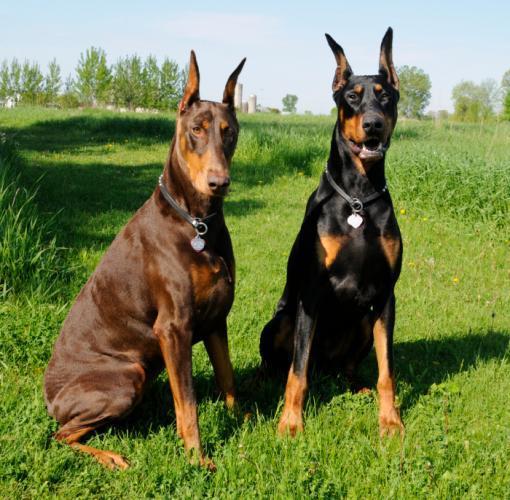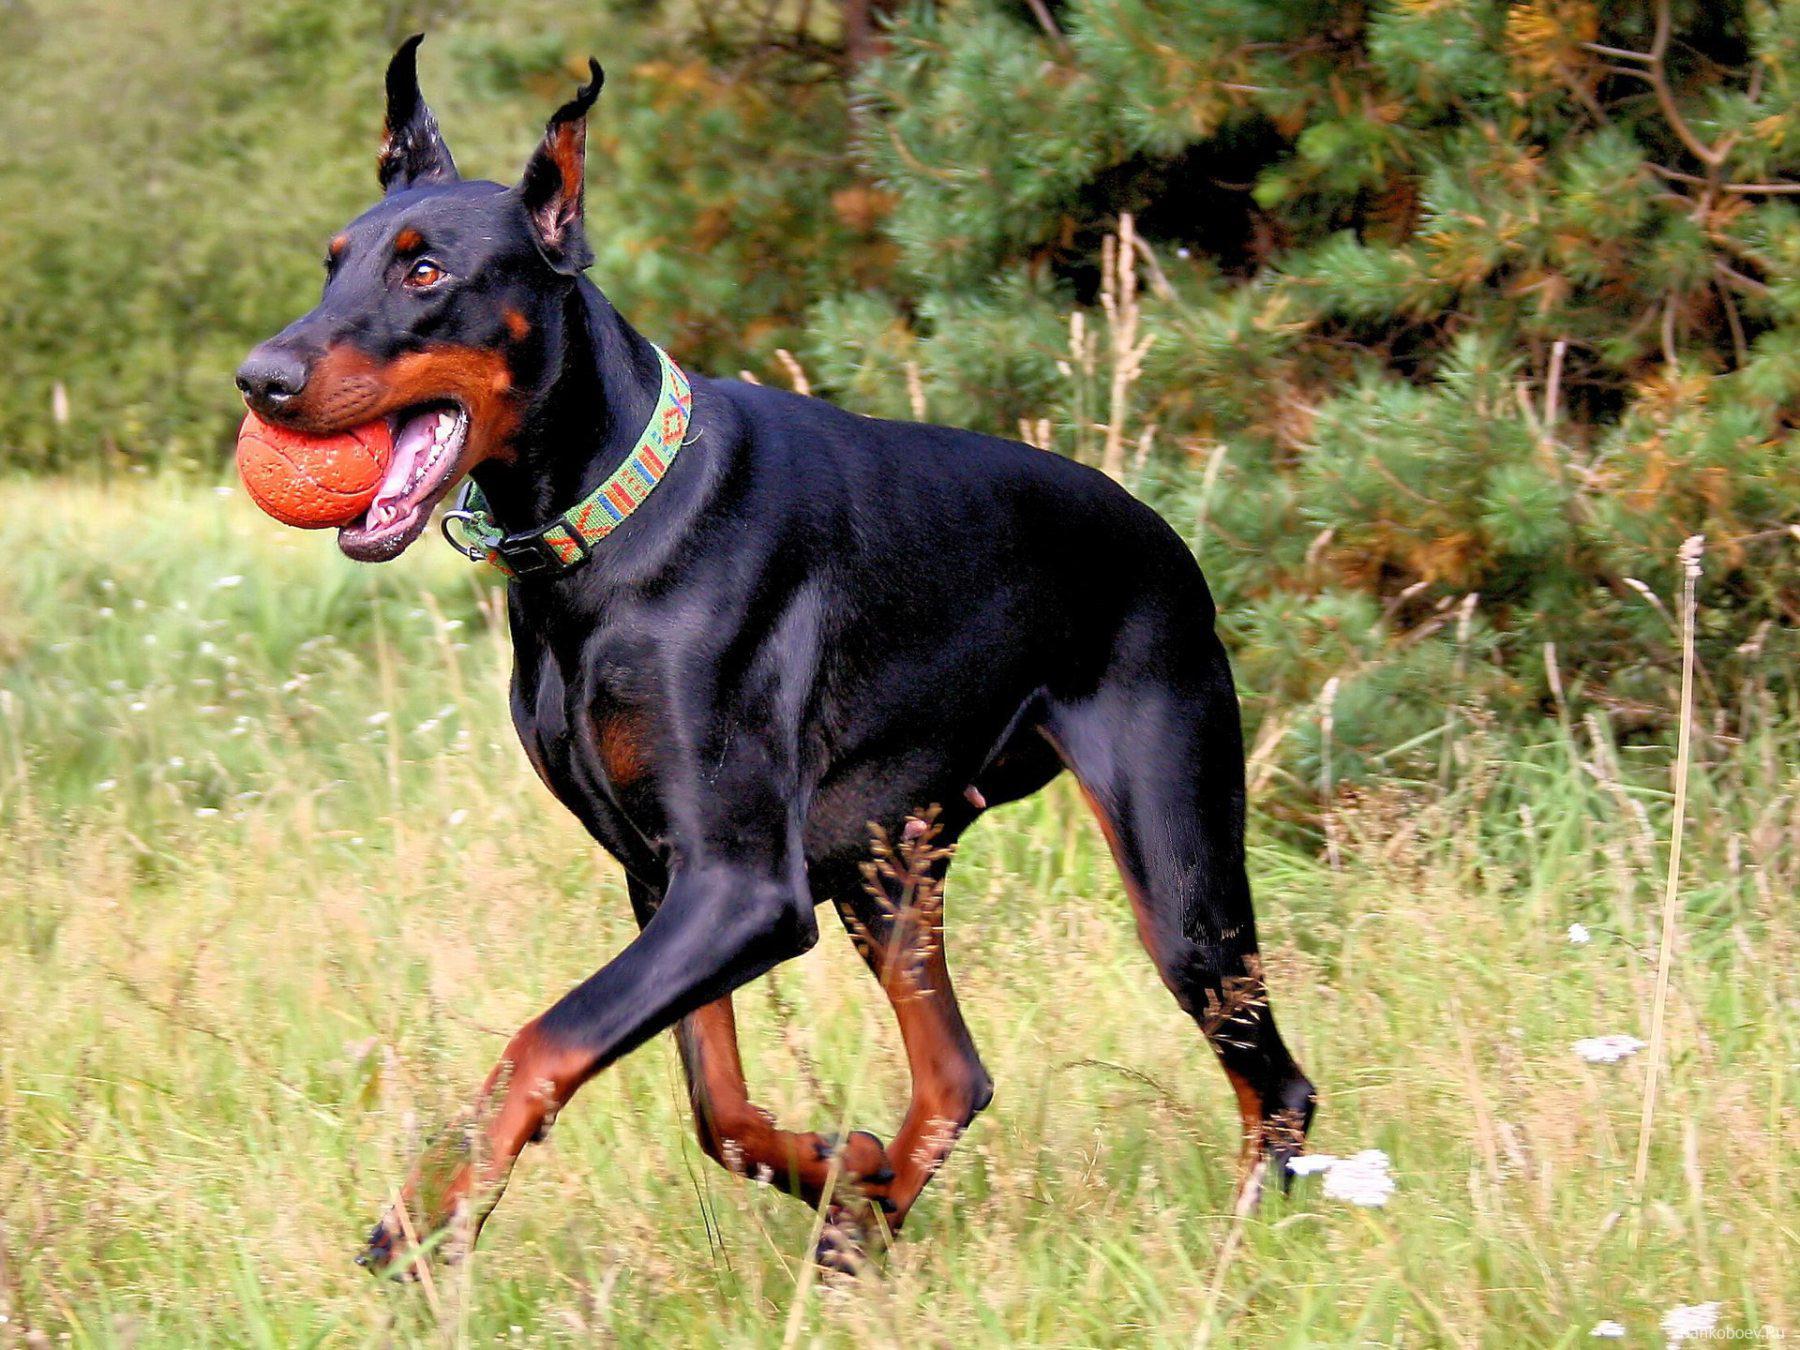The first image is the image on the left, the second image is the image on the right. Given the left and right images, does the statement "At least one dog is lying down on the grass." hold true? Answer yes or no. No. 